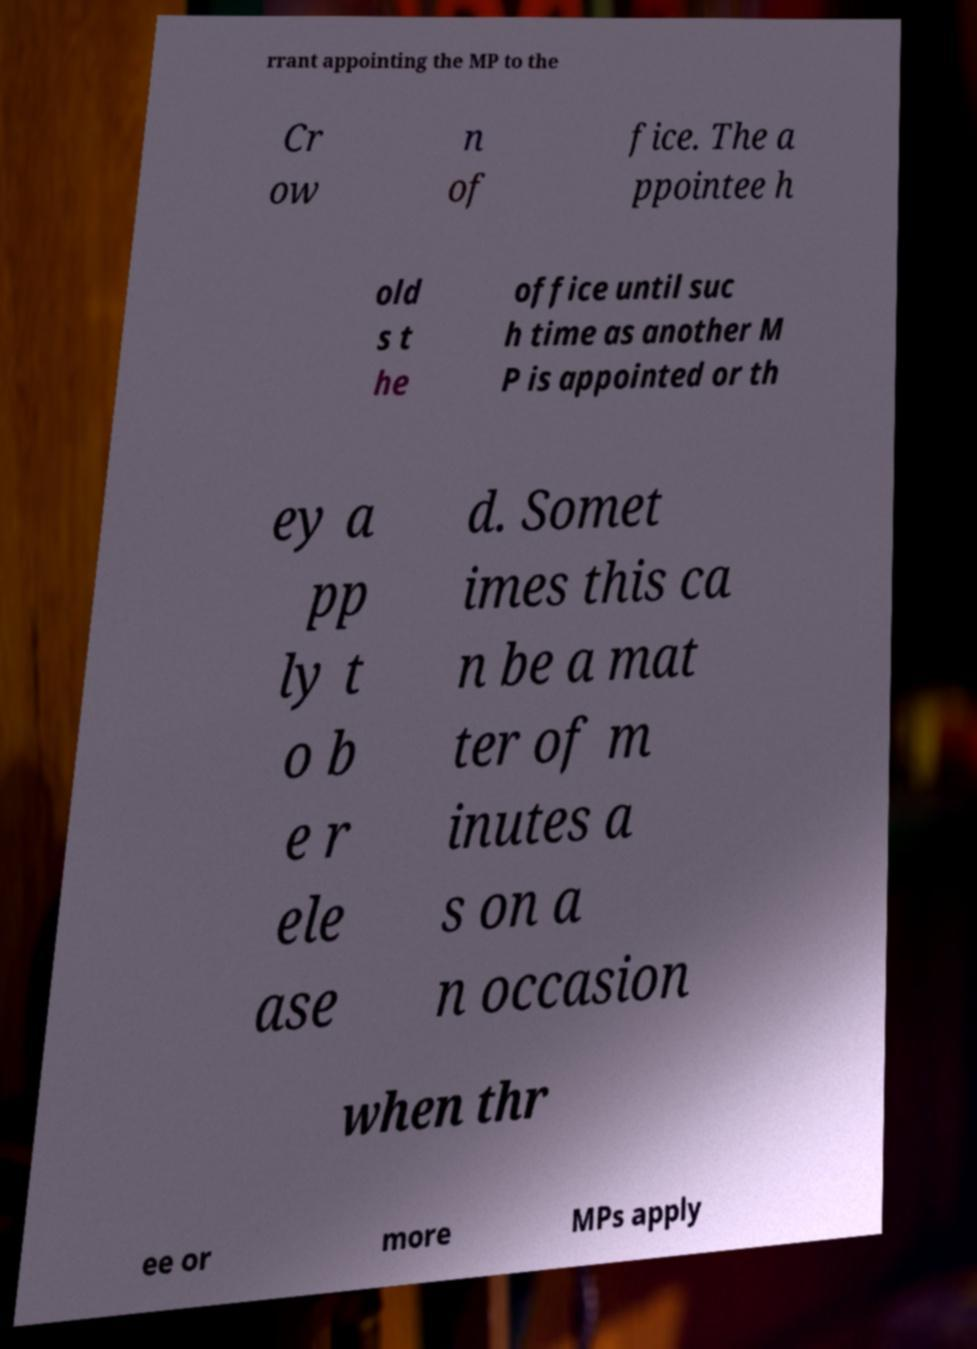Could you extract and type out the text from this image? rrant appointing the MP to the Cr ow n of fice. The a ppointee h old s t he office until suc h time as another M P is appointed or th ey a pp ly t o b e r ele ase d. Somet imes this ca n be a mat ter of m inutes a s on a n occasion when thr ee or more MPs apply 